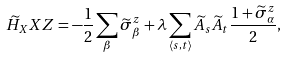Convert formula to latex. <formula><loc_0><loc_0><loc_500><loc_500>\widetilde { H } _ { X } X Z = - \frac { 1 } { 2 } \sum _ { \beta } \widetilde { \sigma } _ { \beta } ^ { z } + \lambda \sum _ { \langle s , t \rangle } \widetilde { A } _ { s } \widetilde { A } _ { t } \frac { 1 + \widetilde { \sigma } _ { \alpha } ^ { z } } { 2 } ,</formula> 